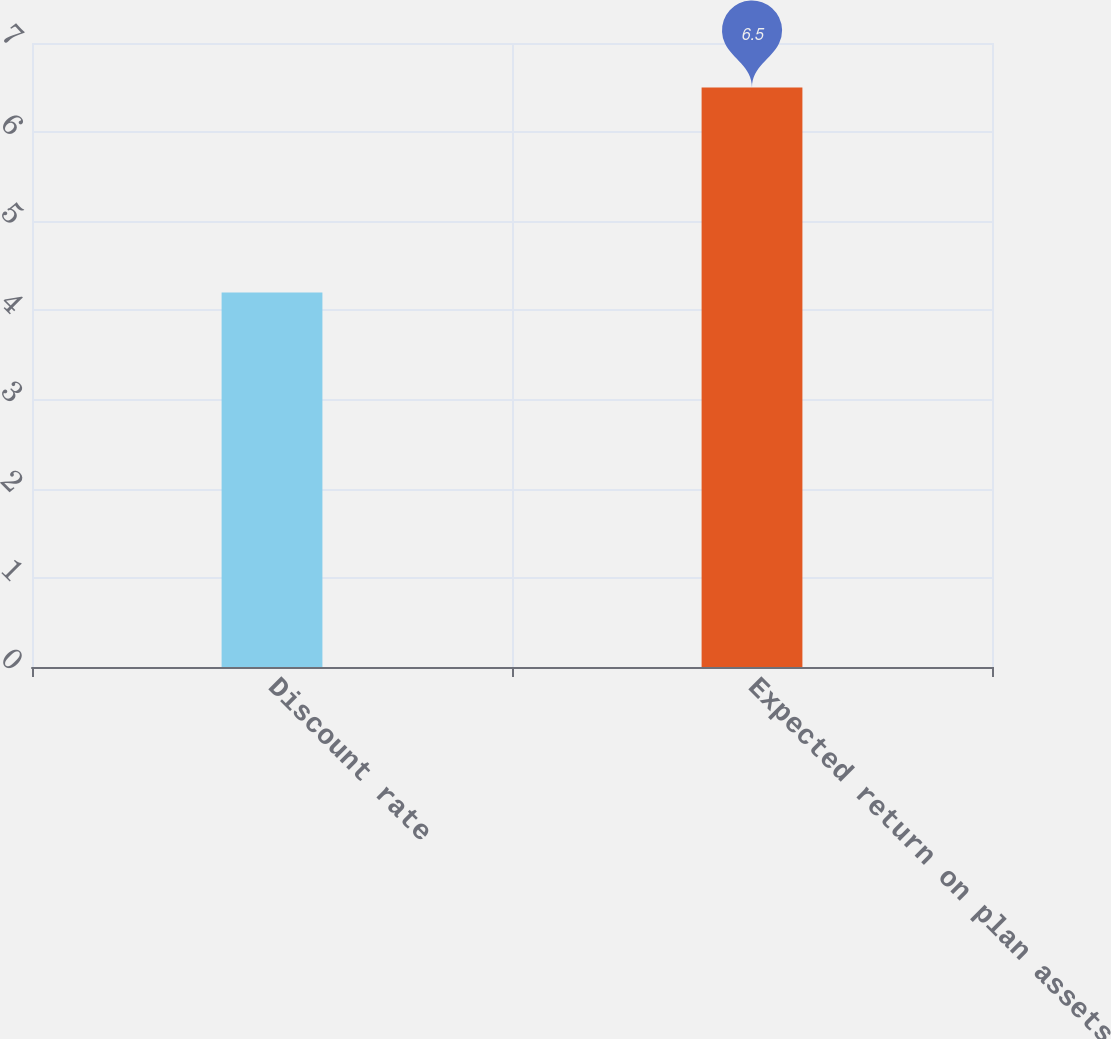Convert chart to OTSL. <chart><loc_0><loc_0><loc_500><loc_500><bar_chart><fcel>Discount rate<fcel>Expected return on plan assets<nl><fcel>4.2<fcel>6.5<nl></chart> 